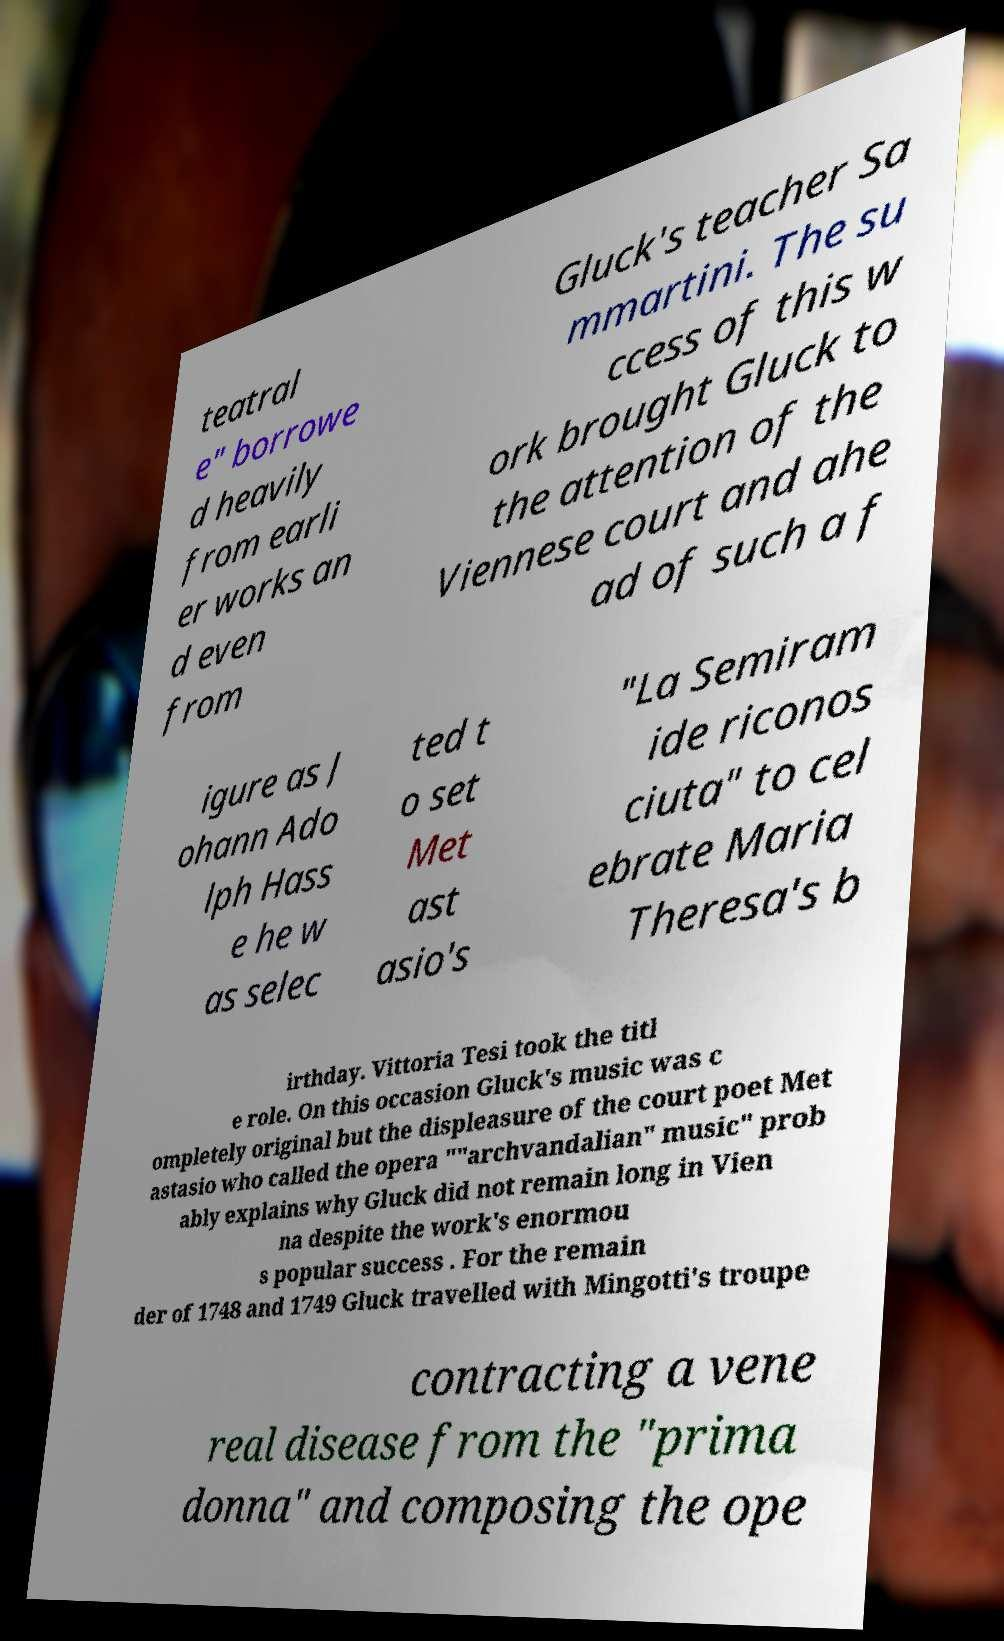For documentation purposes, I need the text within this image transcribed. Could you provide that? teatral e" borrowe d heavily from earli er works an d even from Gluck's teacher Sa mmartini. The su ccess of this w ork brought Gluck to the attention of the Viennese court and ahe ad of such a f igure as J ohann Ado lph Hass e he w as selec ted t o set Met ast asio's "La Semiram ide riconos ciuta" to cel ebrate Maria Theresa's b irthday. Vittoria Tesi took the titl e role. On this occasion Gluck's music was c ompletely original but the displeasure of the court poet Met astasio who called the opera ""archvandalian" music" prob ably explains why Gluck did not remain long in Vien na despite the work's enormou s popular success . For the remain der of 1748 and 1749 Gluck travelled with Mingotti's troupe contracting a vene real disease from the "prima donna" and composing the ope 